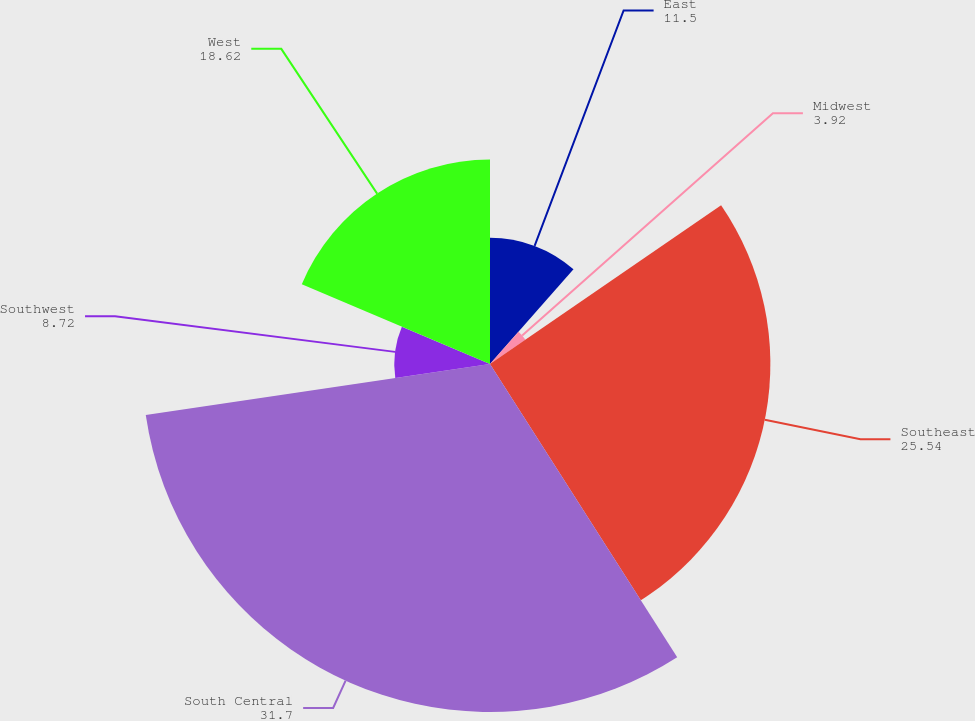Convert chart. <chart><loc_0><loc_0><loc_500><loc_500><pie_chart><fcel>East<fcel>Midwest<fcel>Southeast<fcel>South Central<fcel>Southwest<fcel>West<nl><fcel>11.5%<fcel>3.92%<fcel>25.54%<fcel>31.7%<fcel>8.72%<fcel>18.62%<nl></chart> 